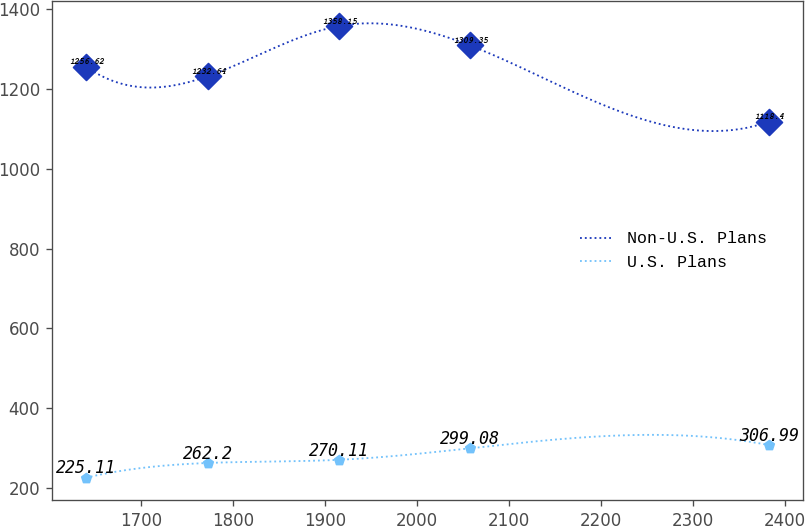<chart> <loc_0><loc_0><loc_500><loc_500><line_chart><ecel><fcel>Non-U.S. Plans<fcel>U.S. Plans<nl><fcel>1640.43<fcel>1256.62<fcel>225.11<nl><fcel>1773.16<fcel>1232.64<fcel>262.2<nl><fcel>1915.48<fcel>1358.15<fcel>270.11<nl><fcel>2057.83<fcel>1309.35<fcel>299.08<nl><fcel>2382.47<fcel>1118.4<fcel>306.99<nl></chart> 